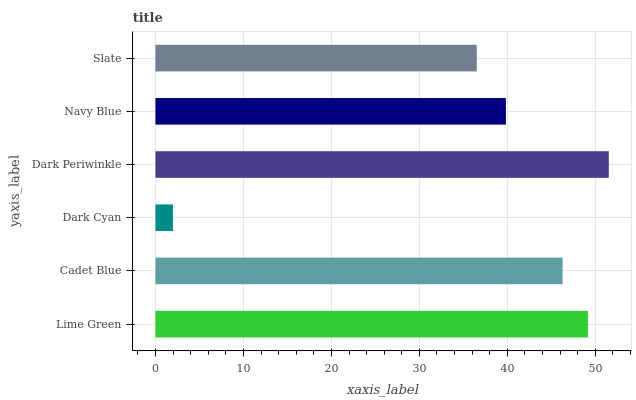Is Dark Cyan the minimum?
Answer yes or no. Yes. Is Dark Periwinkle the maximum?
Answer yes or no. Yes. Is Cadet Blue the minimum?
Answer yes or no. No. Is Cadet Blue the maximum?
Answer yes or no. No. Is Lime Green greater than Cadet Blue?
Answer yes or no. Yes. Is Cadet Blue less than Lime Green?
Answer yes or no. Yes. Is Cadet Blue greater than Lime Green?
Answer yes or no. No. Is Lime Green less than Cadet Blue?
Answer yes or no. No. Is Cadet Blue the high median?
Answer yes or no. Yes. Is Navy Blue the low median?
Answer yes or no. Yes. Is Lime Green the high median?
Answer yes or no. No. Is Slate the low median?
Answer yes or no. No. 